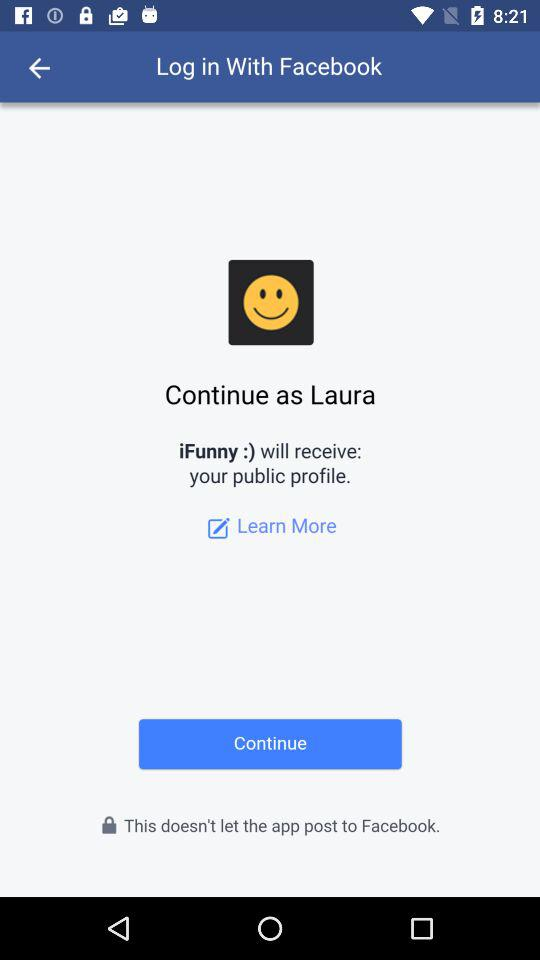By which account log in can be done? The account can be logged in with "Facebook". 